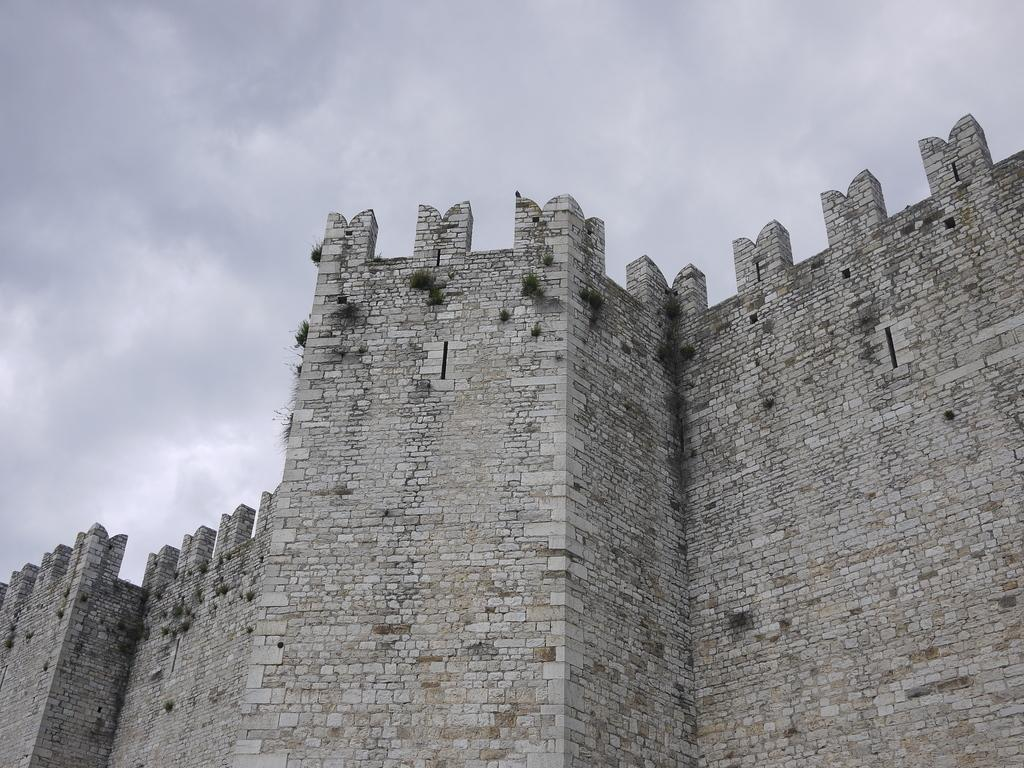What is depicted on the walls in the image? There are planets depicted on the walls in the image. What can be seen in the background of the image? The sky is visible in the background of the image. What is the smell of the alley in the image? There is no alley present in the image, so it is not possible to determine the smell. 